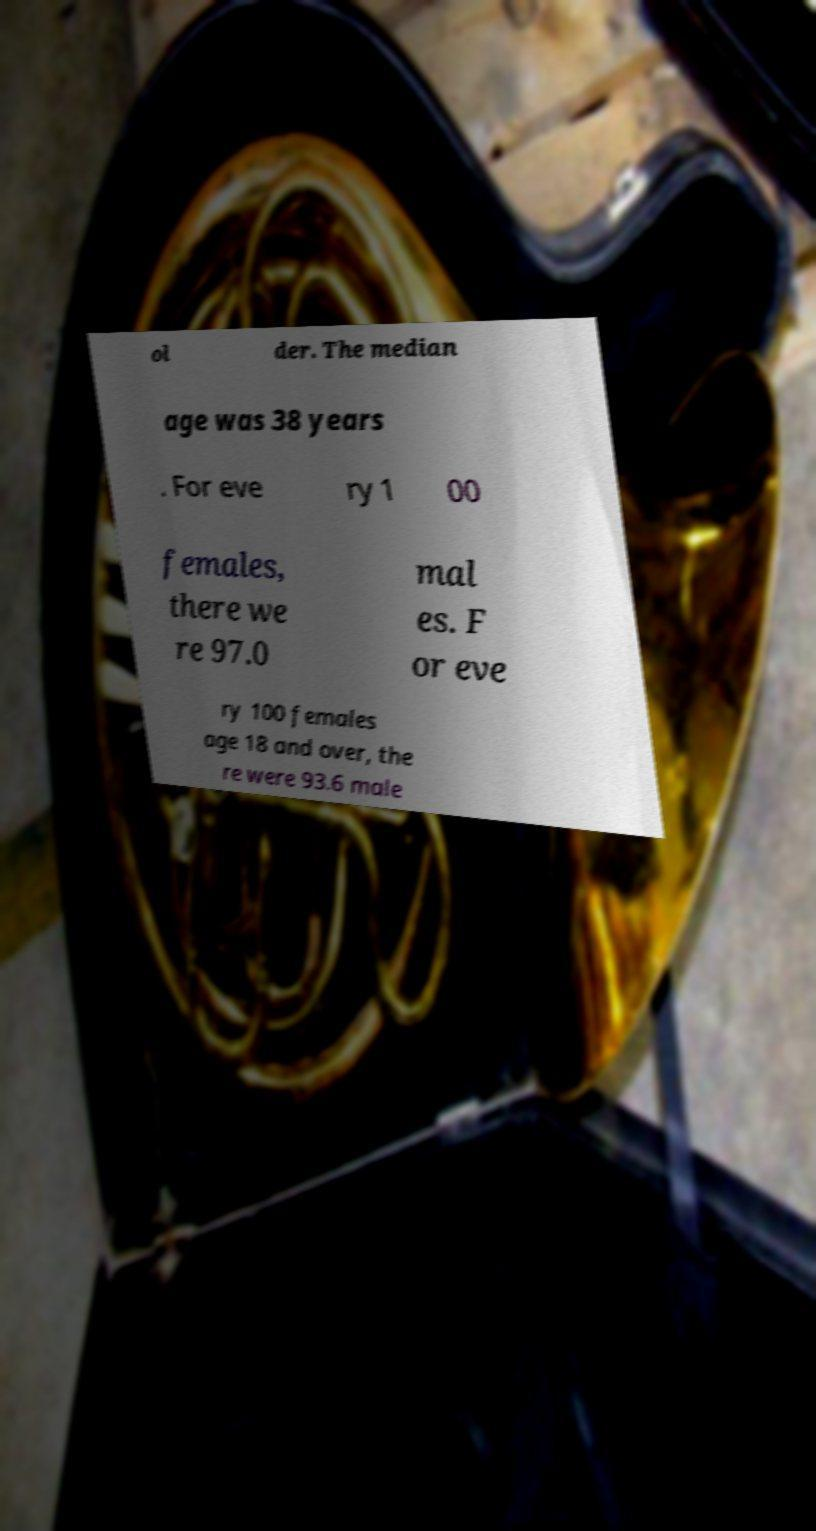What messages or text are displayed in this image? I need them in a readable, typed format. ol der. The median age was 38 years . For eve ry 1 00 females, there we re 97.0 mal es. F or eve ry 100 females age 18 and over, the re were 93.6 male 